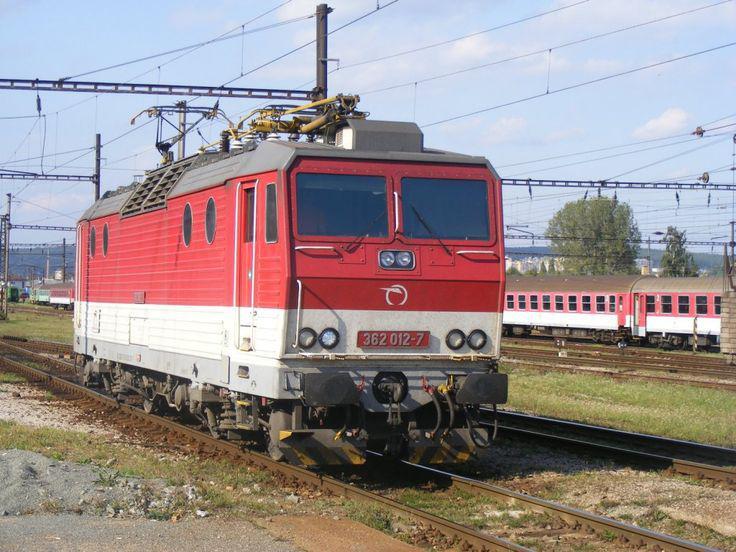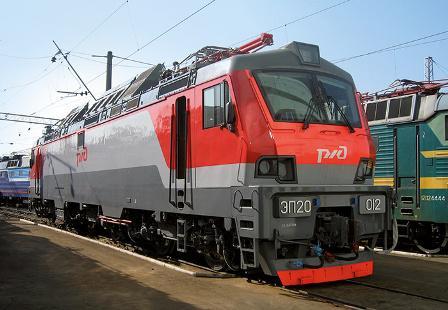The first image is the image on the left, the second image is the image on the right. Assess this claim about the two images: "There are two trains in the image on the right.". Correct or not? Answer yes or no. Yes. 